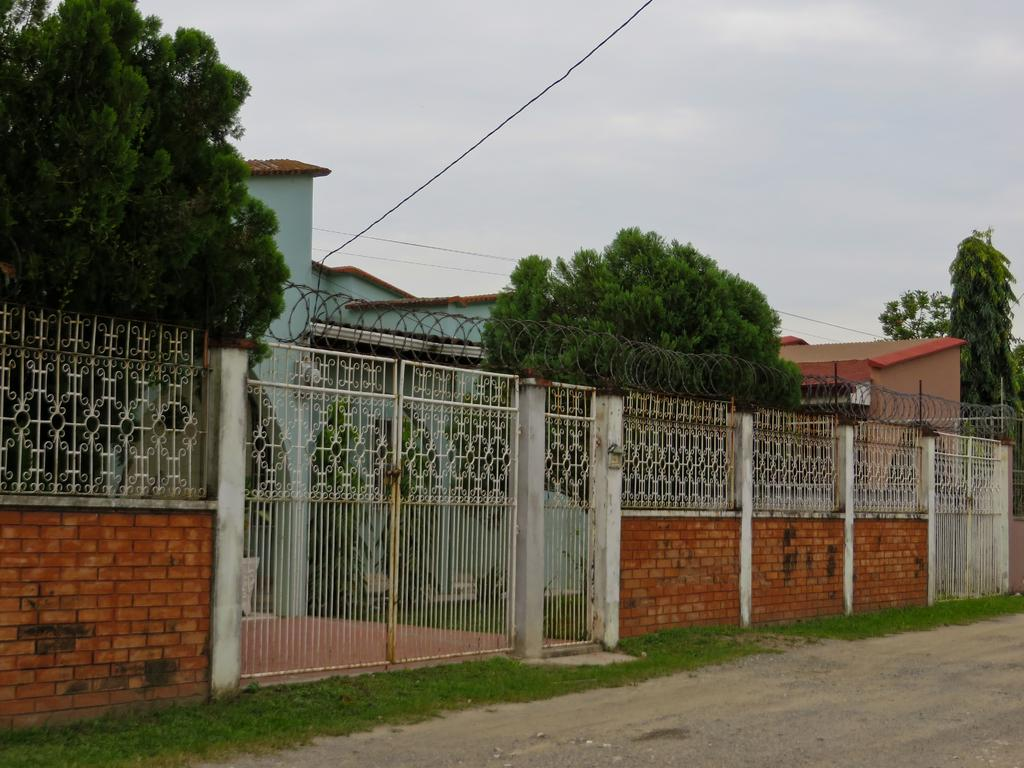What type of structures can be seen in the image? There are buildings in the image. What type of barrier is present in the image? There is fencing in the image. Is there an entrance visible in the image? Yes, there is a gate in the image. What other architectural feature can be seen in the image? There is a wall in the image. What type of vegetation is present in the image? There are trees in the image. What part of the natural environment is visible in the image? The sky is visible in the image. What type of collar can be seen on the yak in the image? There is no yak present in the image, and therefore no collar can be seen. In which bedroom is the image taken? The image does not depict a bedroom, so it is not possible to determine which bedroom the image was taken in. 